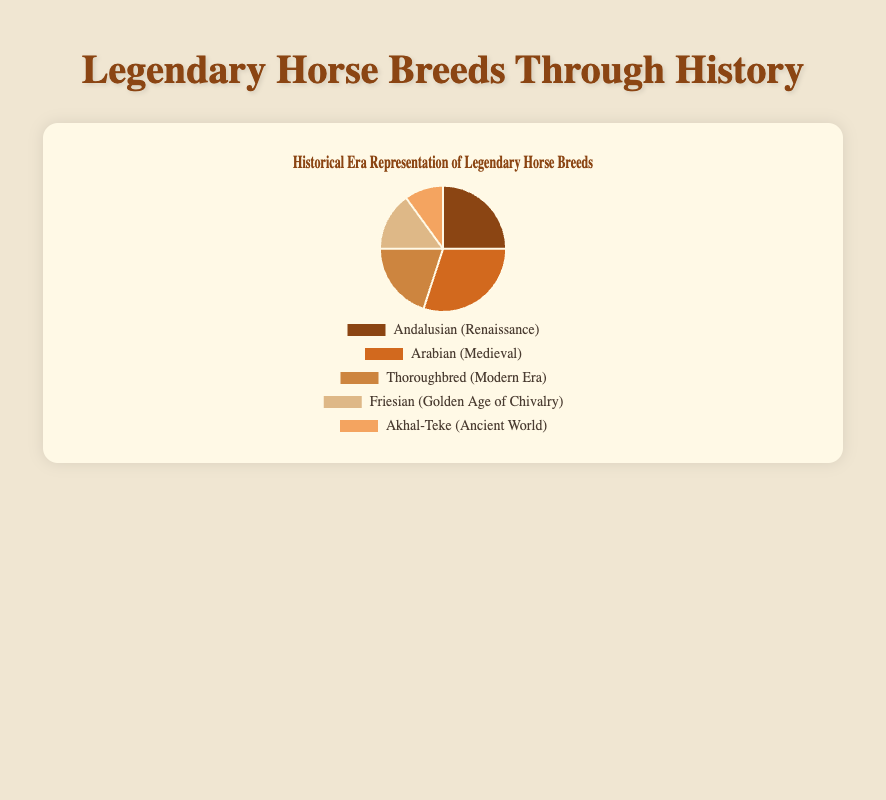Which breed has the highest representation in the chart? The Arabian breed (Medieval) has the highest percentage representation of 30%.
Answer: Arabian Which breed is the least represented in the chart? The Akhal-Teke breed (Ancient World) has the lowest percentage representation of 10%.
Answer: Akhal-Teke What is the combined percentage of the Andalusian and Thoroughbred breeds? The Andalusian breed (Renaissance) has 25%, and the Thoroughbred breed (Modern Era) has 20%. Adding these together gives 25% + 20% = 45%.
Answer: 45% Which era has the second-highest representation? The Renaissance era, represented by the Andalusian breed, has the second-highest percentage of 25%.
Answer: Renaissance What percentage more does the Arabian breed represent compared to the Friesian breed? The Arabian breed (Medieval) has 30%, and the Friesian breed (Golden Age of Chivalry) has 15%. The difference is 30% - 15% = 15%.
Answer: 15% What is the average representation of the five horse breeds in the chart? To find the average, sum all the percentages: 25% (Andalusian) + 30% (Arabian) + 20% (Thoroughbred) + 15% (Friesian) + 10% (Akhal-Teke) = 100%. Then divide by the number of breeds: 100% / 5 = 20%.
Answer: 20% Which breed's representation is exactly half of the Arabian breed's representation? The Arabian breed (Medieval) has 30%. Half of this is 30% / 2 = 15%. The Friesian breed (Golden Age of Chivalry) has 15%.
Answer: Friesian Is the representation of the Thoroughbred breed higher or lower than the combined representation of the Friesian and Akhal-Teke breeds? The Thoroughbred breed (Modern Era) has 20%. The Friesian breed (Golden Age of Chivalry) and Akhal-Teke breed (Ancient World) together have 15% + 10% = 25%. Thus, 20% is less than 25%.
Answer: Lower What’s the visual background color of the segment representing the Friesian breed? The segment representing the Friesian breed is colored in light brown.
Answer: Light brown What is the total percentage representation of the breeds from the Ancient World and the Golden Age of Chivalry? The Akhal-Teke breed (Ancient World) has 10%, and the Friesian breed (Golden Age of Chivalry) has 15%. Adding these together gives 10% + 15% = 25%.
Answer: 25% 